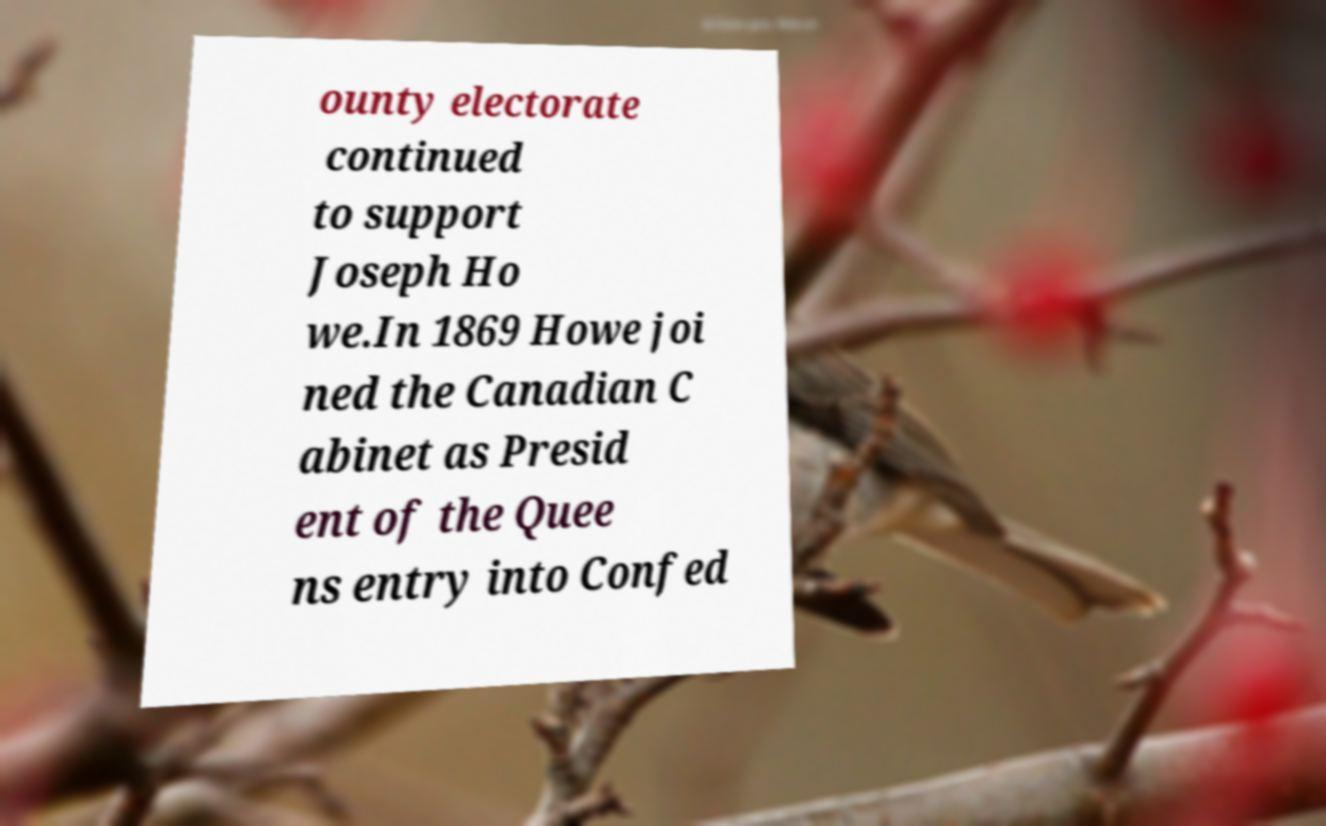Can you read and provide the text displayed in the image?This photo seems to have some interesting text. Can you extract and type it out for me? ounty electorate continued to support Joseph Ho we.In 1869 Howe joi ned the Canadian C abinet as Presid ent of the Quee ns entry into Confed 